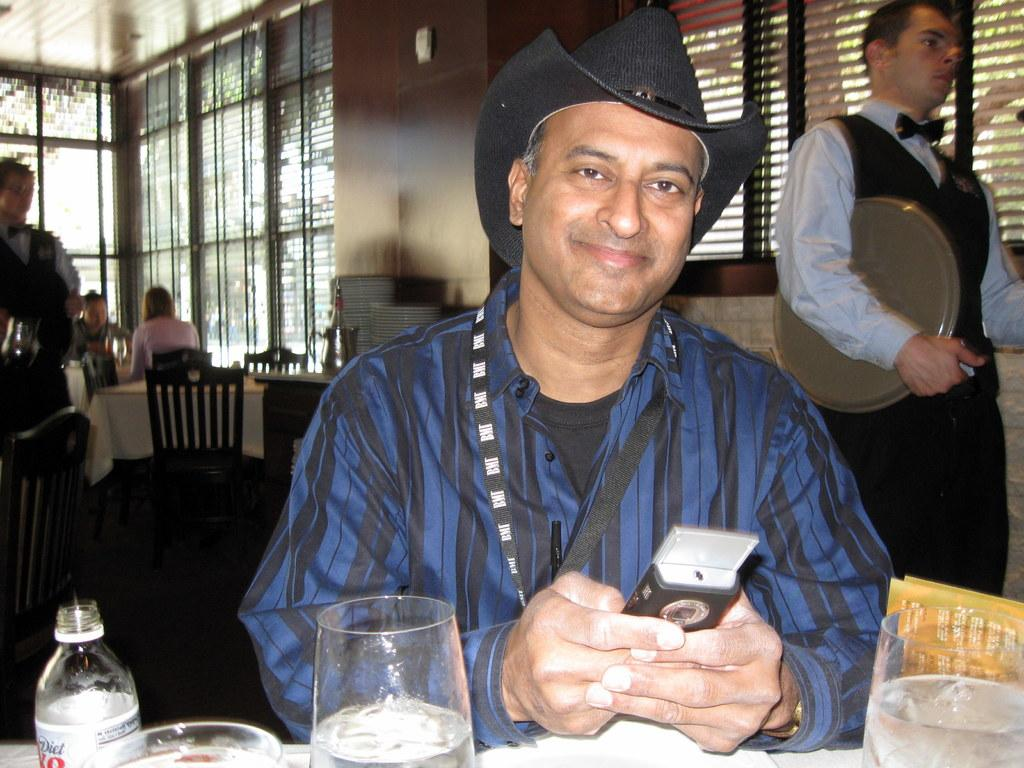Who is present in the image? There is a man in the image. What is the man holding in the image? The man is holding a phone. What objects can be seen in the image besides the man and his phone? There are glasses and a bottle in the image. What type of furniture is visible in the background of the image? Chairs and tables are present in the background of the image. What else can be seen in the background of the image? There are people and windows visible in the background. What type of dog can be seen playing with a cart in the image? There is no dog or cart present in the image. Are there any flowers visible in the image? There is no mention of flowers in the provided facts, so we cannot determine if they are present in the image. 